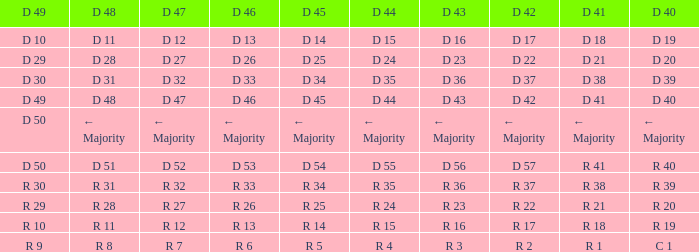I desire the d 46 for d 45 of r 5 R 6. 